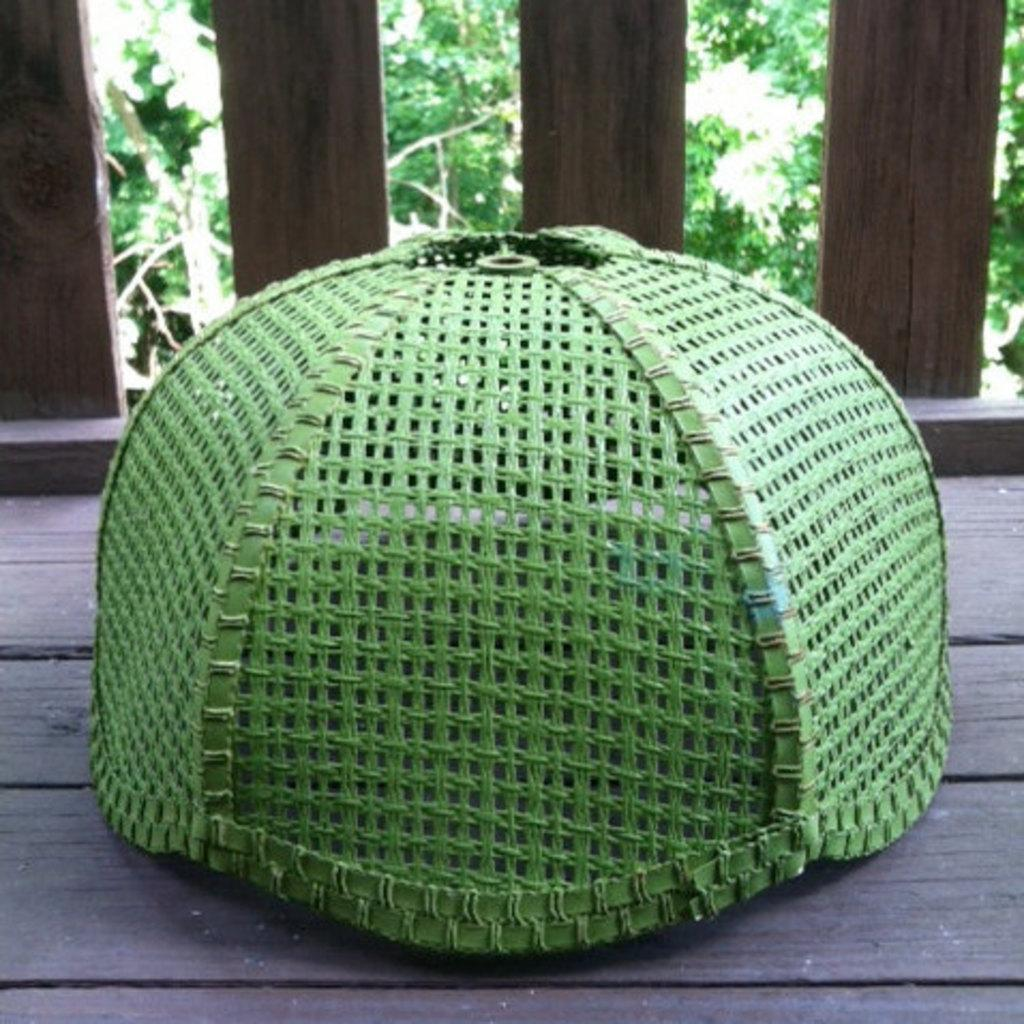What structure can be seen in the image? There is a cage in the image. What type of surface is at the bottom of the image? There is a wooden surface at the bottom of the image. What type of natural environment is visible in the image? There are trees visible in the image. What type of secretary is sitting on the wooden surface in the image? There is no secretary present in the image; it only features a cage and trees. What type of twig can be seen in the cage in the image? There is no twig visible in the cage in the image. 